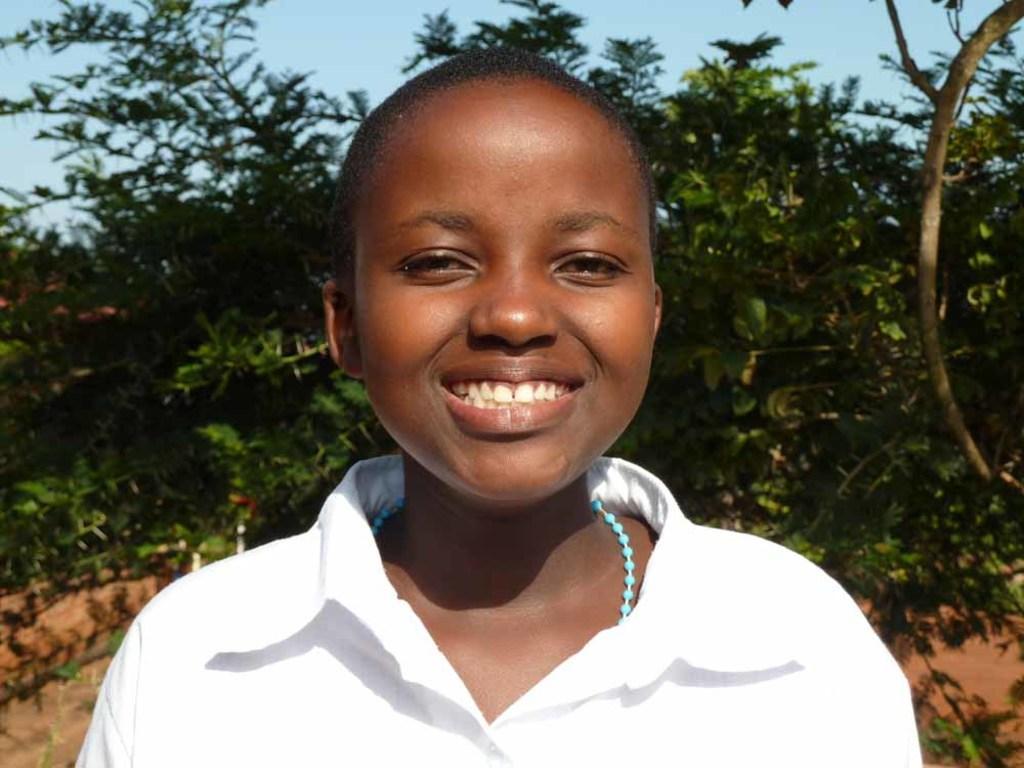Can you describe this image briefly? In this image, we can see a person. In the background, we can see some trees and the sky. 